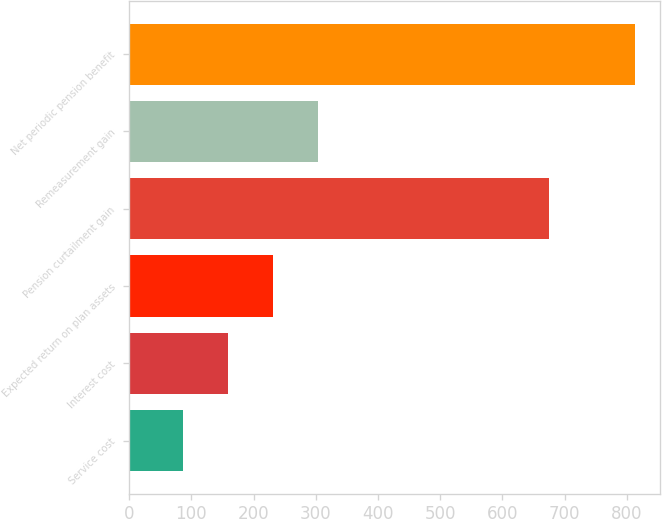<chart> <loc_0><loc_0><loc_500><loc_500><bar_chart><fcel>Service cost<fcel>Interest cost<fcel>Expected return on plan assets<fcel>Pension curtailment gain<fcel>Remeasurement gain<fcel>Net periodic pension benefit<nl><fcel>86<fcel>158.7<fcel>231.4<fcel>675<fcel>304.1<fcel>813<nl></chart> 